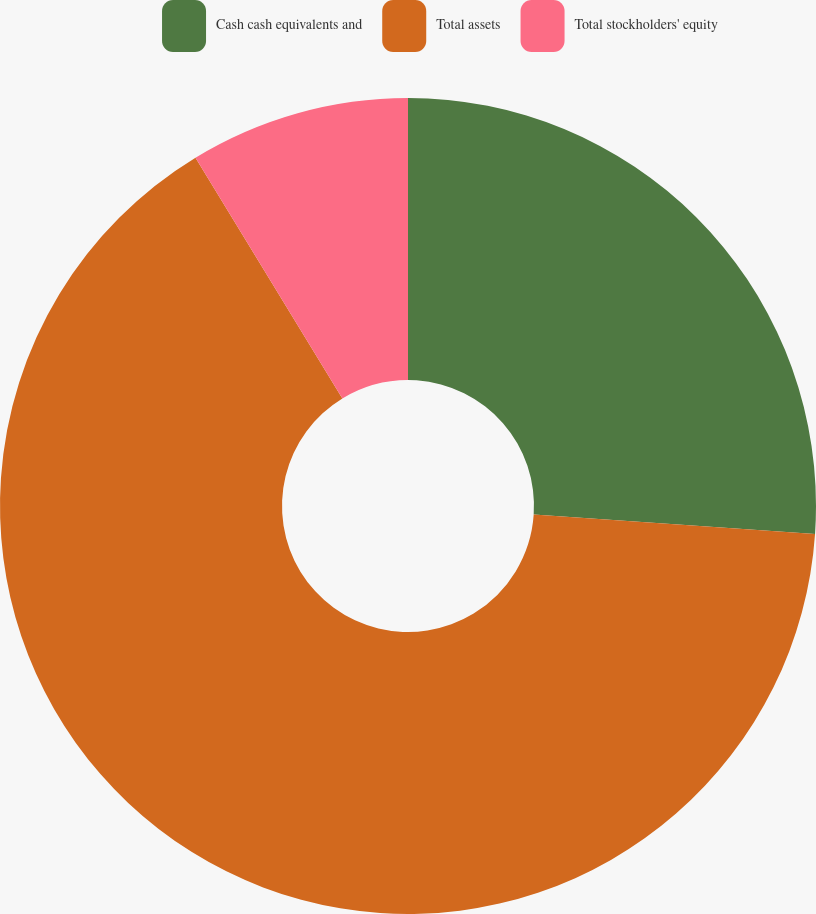<chart> <loc_0><loc_0><loc_500><loc_500><pie_chart><fcel>Cash cash equivalents and<fcel>Total assets<fcel>Total stockholders' equity<nl><fcel>26.09%<fcel>65.19%<fcel>8.72%<nl></chart> 